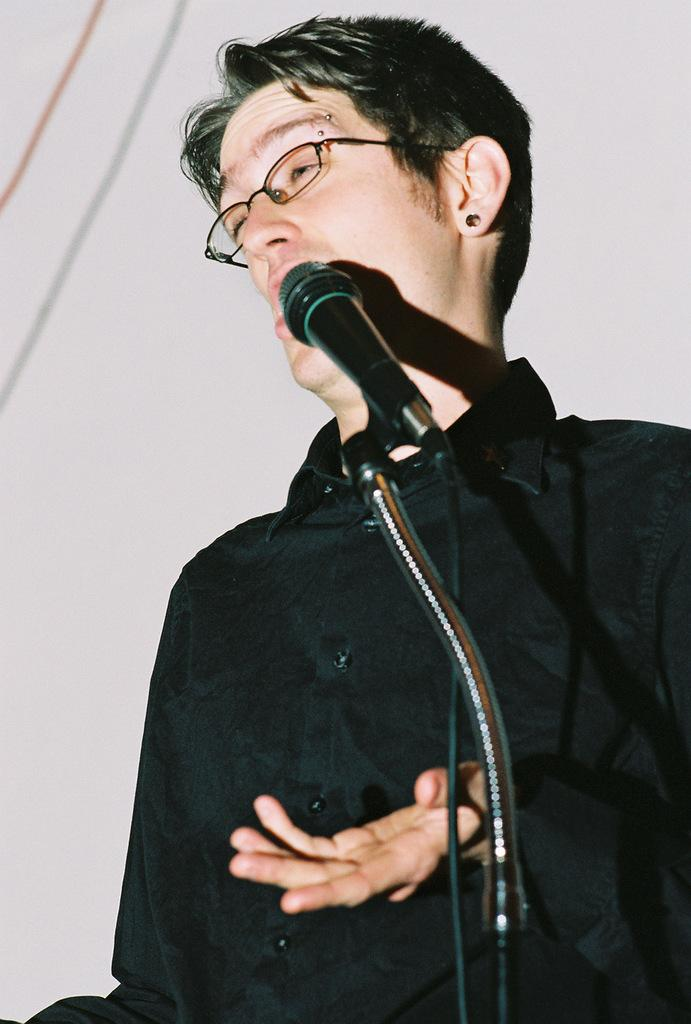What is the main subject of the image? The main subject of the image is a man. What is the man doing in the image? The man is speaking on a microphone. What color is the shirt the man is wearing? The man is wearing a black color shirt. Are there any accessories visible on the man in the image? Yes, the man has spectacles. How many dimes can be seen on the man's head in the image? There are no dimes visible on the man's head in the image. What type of drug is the man taking in the image? There is no indication of the man taking any drug in the image. 